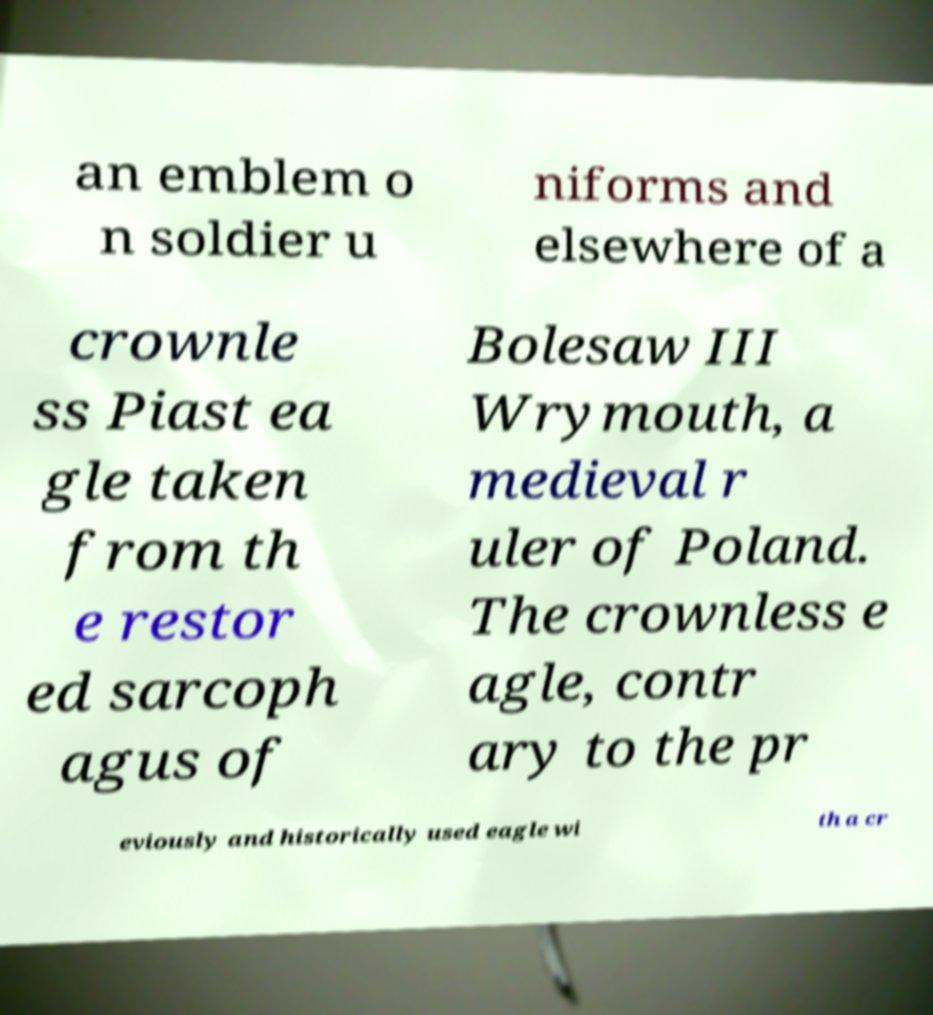Could you extract and type out the text from this image? an emblem o n soldier u niforms and elsewhere of a crownle ss Piast ea gle taken from th e restor ed sarcoph agus of Bolesaw III Wrymouth, a medieval r uler of Poland. The crownless e agle, contr ary to the pr eviously and historically used eagle wi th a cr 